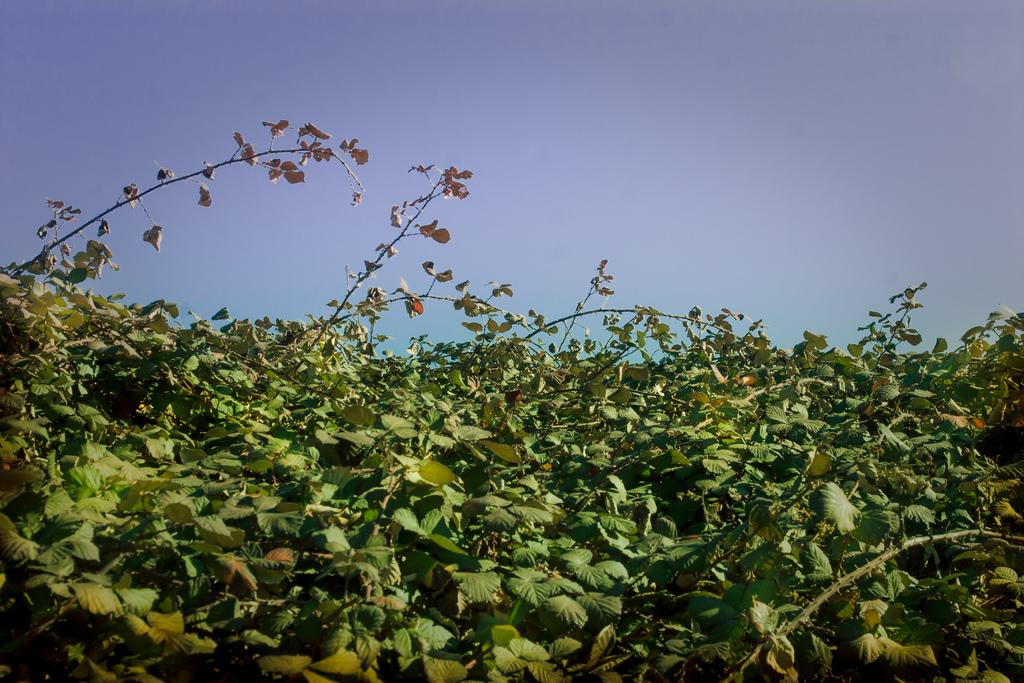What type of vegetation is present in the image? There are trees with branches and leaves in the image. What part of the natural environment can be seen in the image? The sky is visible in the image. How many cakes are being served by the zebra in the image? There is no zebra present in the image, and therefore no cakes are being served. 